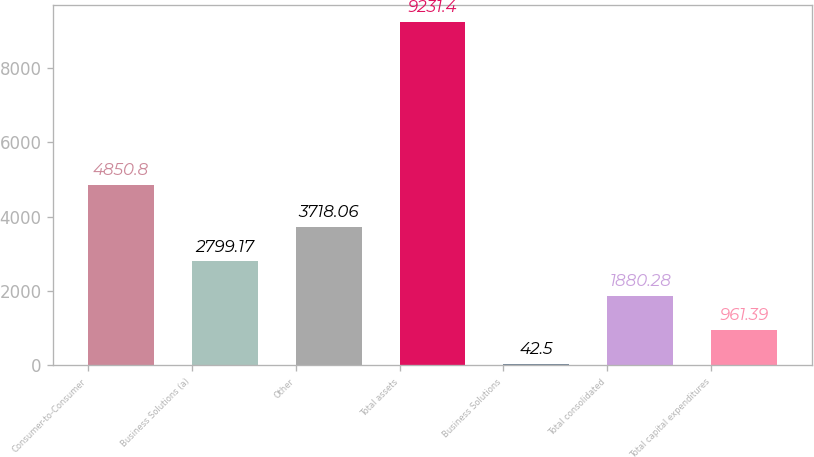Convert chart to OTSL. <chart><loc_0><loc_0><loc_500><loc_500><bar_chart><fcel>Consumer-to-Consumer<fcel>Business Solutions (a)<fcel>Other<fcel>Total assets<fcel>Business Solutions<fcel>Total consolidated<fcel>Total capital expenditures<nl><fcel>4850.8<fcel>2799.17<fcel>3718.06<fcel>9231.4<fcel>42.5<fcel>1880.28<fcel>961.39<nl></chart> 